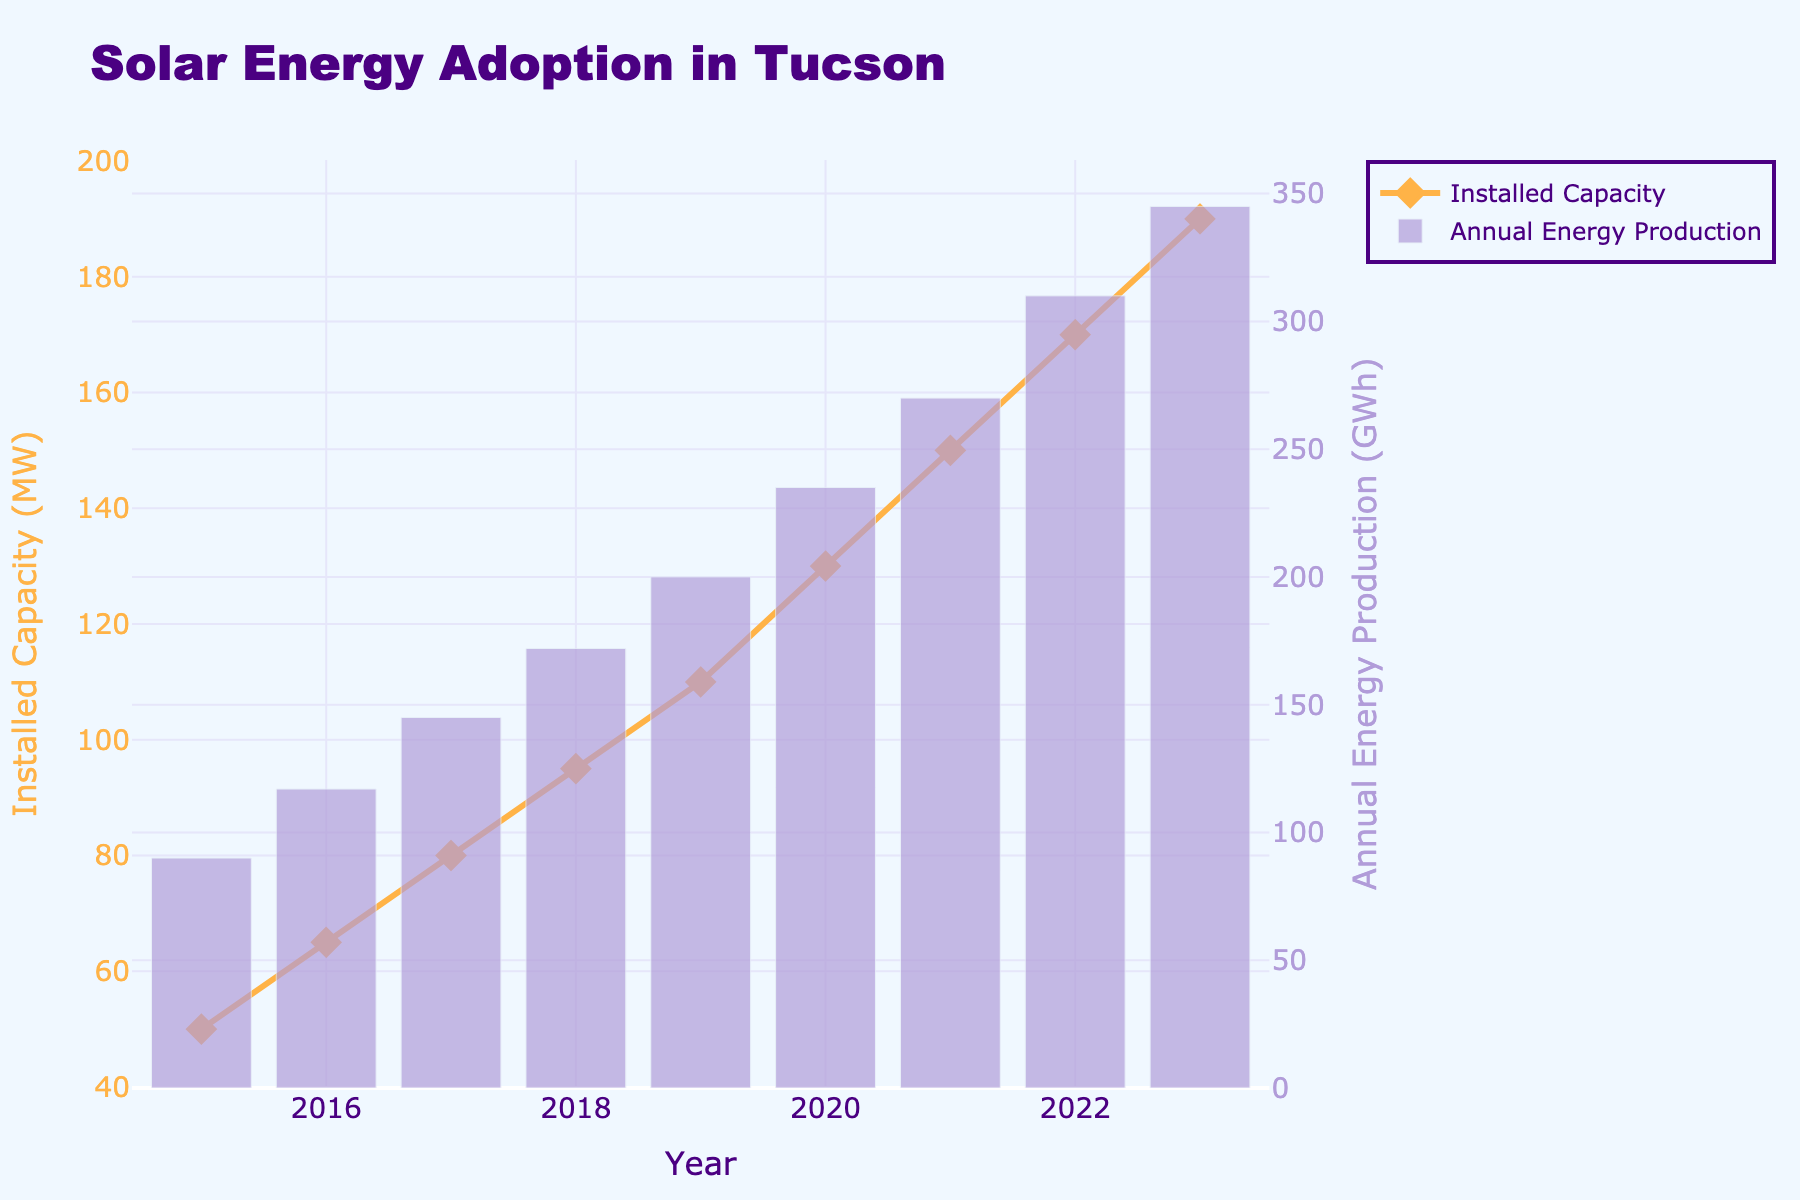What is the title of the plot? The title of the plot can be found at the top of the figure. It reads "Solar Energy Adoption in Tucson".
Answer: Solar Energy Adoption in Tucson Which year had the highest installed solar capacity? To find the year with the highest installed capacity, observe the line plot (yellow-orange line) and locate the highest point. The year corresponding to this point is 2023.
Answer: 2023 What was the annual energy production in 2019? Look at the bar for the year 2019 in the bar chart. The height of the bar corresponds to the annual energy production, which is labeled in GWh and reads 200 GWh for 2019.
Answer: 200 GWh How did the installed capacity change from 2015 to 2023? The installed capacity in 2015 was 50 MW and in 2023 it was 190 MW. Calculate the difference by subtracting the 2015 value from the 2023 value: 190 - 50 = 140 MW.
Answer: 140 MW What is the trend of annual energy production from 2015 to 2023? By examining the height of the bars from 2015 to 2023, it is evident that the annual energy production consistently increases over the years. This indicates a positive upward trend.
Answer: Increasing Which year had the largest increase in installed capacity compared to the previous year? Compare the year-to-year changes in the line plot. The largest change is observed between 2019 (110 MW) and 2020 (130 MW). The increase is 130 - 110 = 20 MW.
Answer: 2020 How many MW of installed capacity were added between 2018 and 2019? To find this, subtract the installed capacity in 2018 from that in 2019. The installed capacities are 95 MW and 110 MW respectively. Hence, 110 - 95 = 15 MW.
Answer: 15 MW Compare the annual energy production in 2020 and 2021. Which year had higher production and by how much? The annual energy production was 235 GWh in 2020 and 270 GWh in 2021. Calculate the difference: 270 - 235 = 35 GWh. 2021 had higher production by 35 GWh.
Answer: 2021 by 35 GWh What was the installed capacity in 2017, and how does it compare to that in 2015? In 2017, the installed capacity was 80 MW. In 2015, it was 50 MW. The increase is 80 - 50 = 30 MW.
Answer: 30 MW increase What color represents the annual energy production bars in the figure? The color of the bars representing annual energy production can be observed to be in shades of purple.
Answer: Purple 